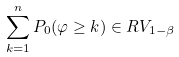<formula> <loc_0><loc_0><loc_500><loc_500>\sum _ { k = 1 } ^ { n } P _ { 0 } ( \varphi \geq k ) \in R V _ { 1 - \beta }</formula> 